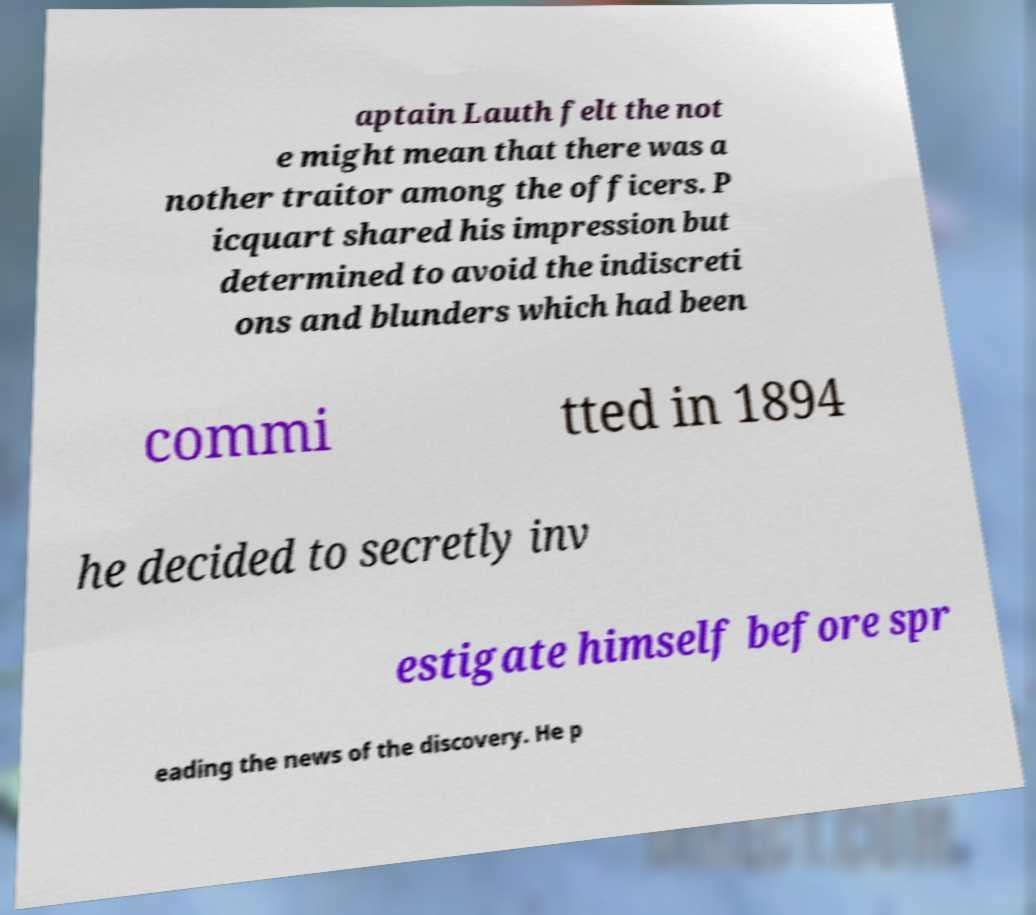Can you accurately transcribe the text from the provided image for me? aptain Lauth felt the not e might mean that there was a nother traitor among the officers. P icquart shared his impression but determined to avoid the indiscreti ons and blunders which had been commi tted in 1894 he decided to secretly inv estigate himself before spr eading the news of the discovery. He p 